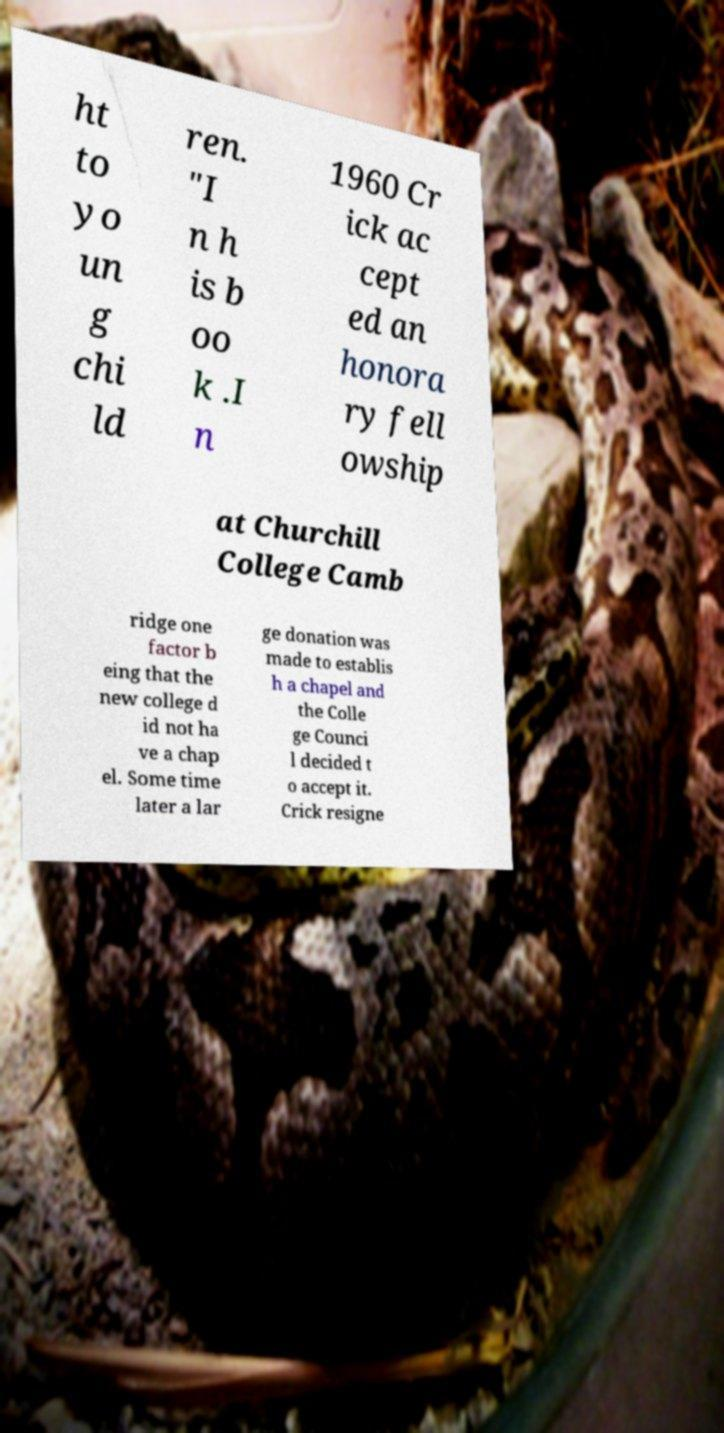For documentation purposes, I need the text within this image transcribed. Could you provide that? ht to yo un g chi ld ren. "I n h is b oo k .I n 1960 Cr ick ac cept ed an honora ry fell owship at Churchill College Camb ridge one factor b eing that the new college d id not ha ve a chap el. Some time later a lar ge donation was made to establis h a chapel and the Colle ge Counci l decided t o accept it. Crick resigne 